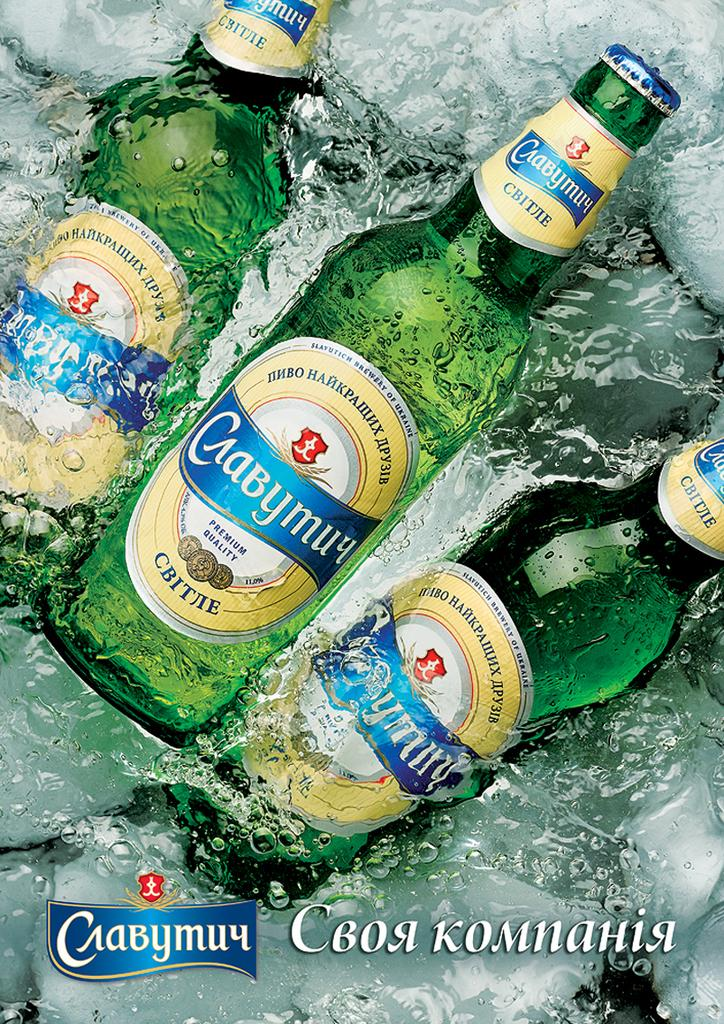Provide a one-sentence caption for the provided image. Green bottles filled with a premium quality beer sit on ice. 